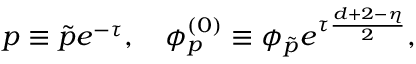<formula> <loc_0><loc_0><loc_500><loc_500>p \equiv \tilde { p } e ^ { - \tau } , \quad p h i _ { p } ^ { ( 0 ) } \equiv \phi _ { \tilde { p } } e ^ { \tau \frac { d + 2 - \eta } { 2 } } ,</formula> 